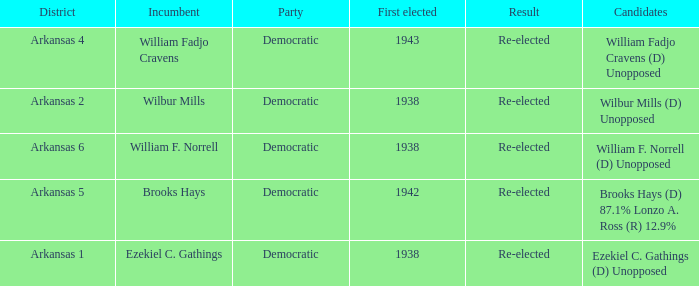What party did the incumbent from the Arkansas 5 district belong to?  Democratic. 